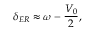Convert formula to latex. <formula><loc_0><loc_0><loc_500><loc_500>\delta _ { E R } \approx \omega - \frac { V _ { 0 } } { 2 } ,</formula> 